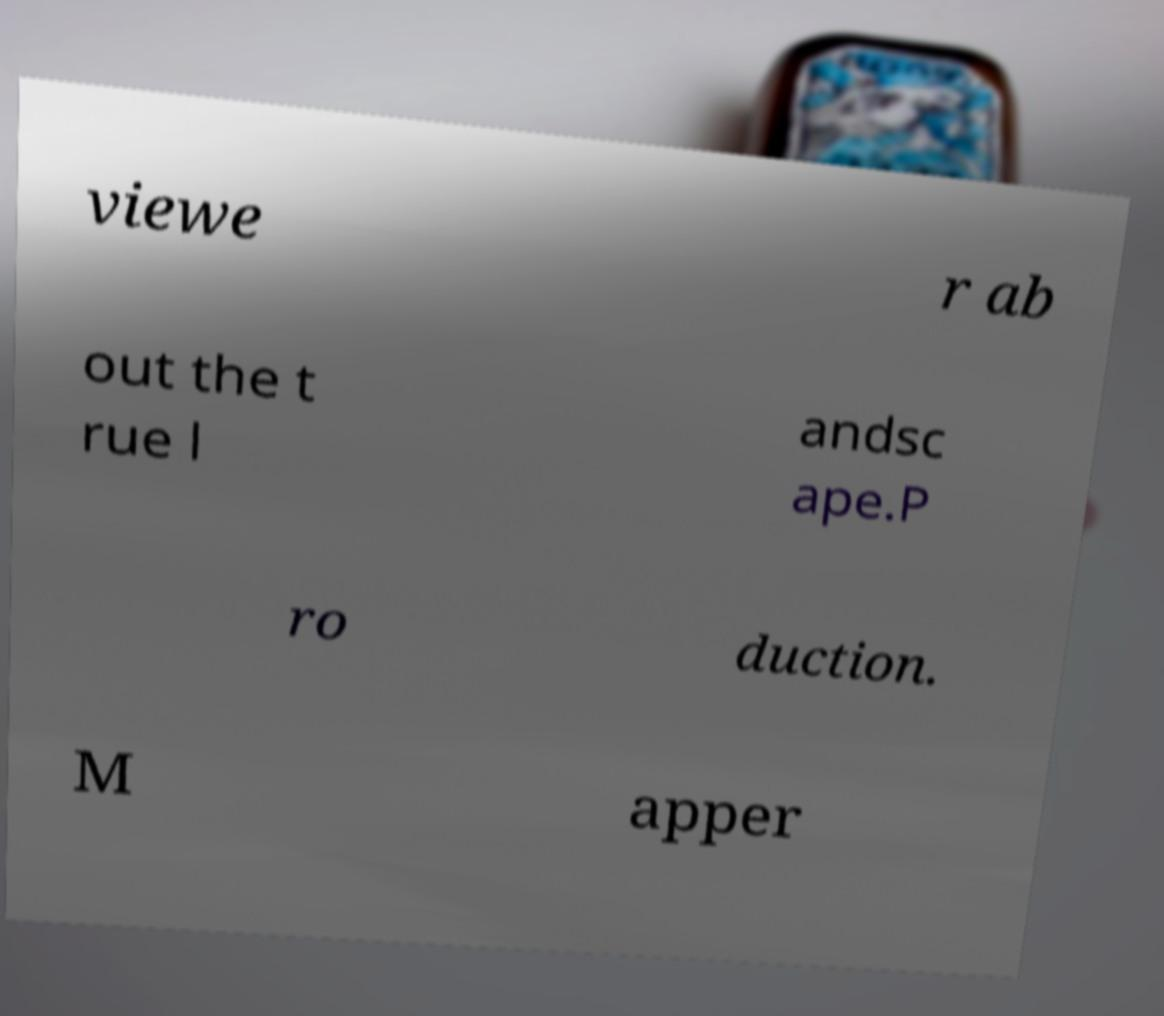Please read and relay the text visible in this image. What does it say? viewe r ab out the t rue l andsc ape.P ro duction. M apper 